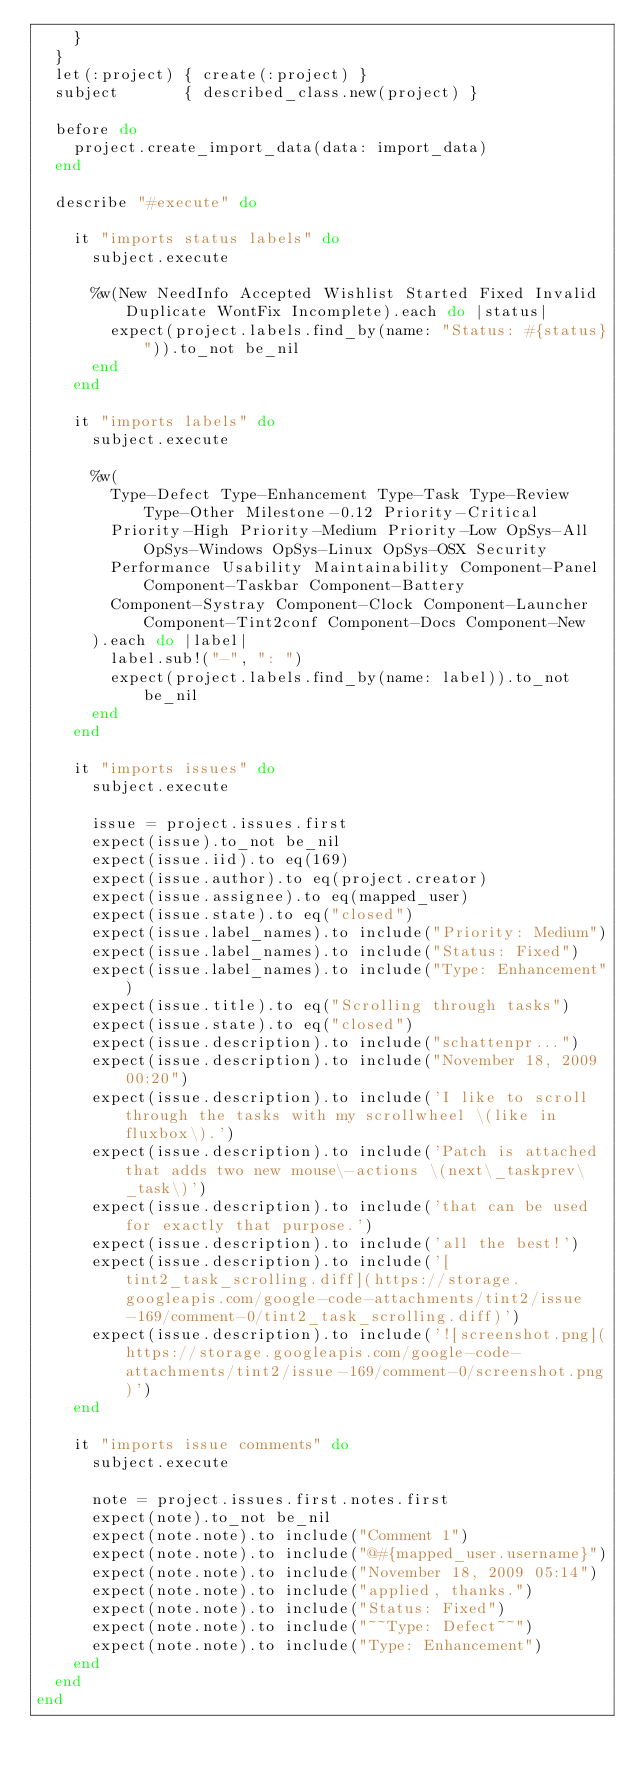Convert code to text. <code><loc_0><loc_0><loc_500><loc_500><_Ruby_>    } 
  }
  let(:project) { create(:project) }
  subject       { described_class.new(project) }

  before do
    project.create_import_data(data: import_data)
  end

  describe "#execute" do

    it "imports status labels" do
      subject.execute

      %w(New NeedInfo Accepted Wishlist Started Fixed Invalid Duplicate WontFix Incomplete).each do |status|
        expect(project.labels.find_by(name: "Status: #{status}")).to_not be_nil
      end
    end

    it "imports labels" do
      subject.execute

      %w(
        Type-Defect Type-Enhancement Type-Task Type-Review Type-Other Milestone-0.12 Priority-Critical 
        Priority-High Priority-Medium Priority-Low OpSys-All OpSys-Windows OpSys-Linux OpSys-OSX Security 
        Performance Usability Maintainability Component-Panel Component-Taskbar Component-Battery 
        Component-Systray Component-Clock Component-Launcher Component-Tint2conf Component-Docs Component-New
      ).each do |label|
        label.sub!("-", ": ")
        expect(project.labels.find_by(name: label)).to_not be_nil
      end
    end

    it "imports issues" do
      subject.execute

      issue = project.issues.first
      expect(issue).to_not be_nil
      expect(issue.iid).to eq(169)
      expect(issue.author).to eq(project.creator)
      expect(issue.assignee).to eq(mapped_user)
      expect(issue.state).to eq("closed")
      expect(issue.label_names).to include("Priority: Medium")
      expect(issue.label_names).to include("Status: Fixed")
      expect(issue.label_names).to include("Type: Enhancement")
      expect(issue.title).to eq("Scrolling through tasks")
      expect(issue.state).to eq("closed")
      expect(issue.description).to include("schattenpr...")
      expect(issue.description).to include("November 18, 2009 00:20")
      expect(issue.description).to include('I like to scroll through the tasks with my scrollwheel \(like in fluxbox\).')
      expect(issue.description).to include('Patch is attached that adds two new mouse\-actions \(next\_taskprev\_task\)')
      expect(issue.description).to include('that can be used for exactly that purpose.')
      expect(issue.description).to include('all the best!')
      expect(issue.description).to include('[tint2_task_scrolling.diff](https://storage.googleapis.com/google-code-attachments/tint2/issue-169/comment-0/tint2_task_scrolling.diff)')
      expect(issue.description).to include('![screenshot.png](https://storage.googleapis.com/google-code-attachments/tint2/issue-169/comment-0/screenshot.png)')
    end

    it "imports issue comments" do
      subject.execute

      note = project.issues.first.notes.first
      expect(note).to_not be_nil
      expect(note.note).to include("Comment 1")
      expect(note.note).to include("@#{mapped_user.username}")
      expect(note.note).to include("November 18, 2009 05:14")
      expect(note.note).to include("applied, thanks.")
      expect(note.note).to include("Status: Fixed")
      expect(note.note).to include("~~Type: Defect~~")
      expect(note.note).to include("Type: Enhancement")
    end
  end
end
</code> 